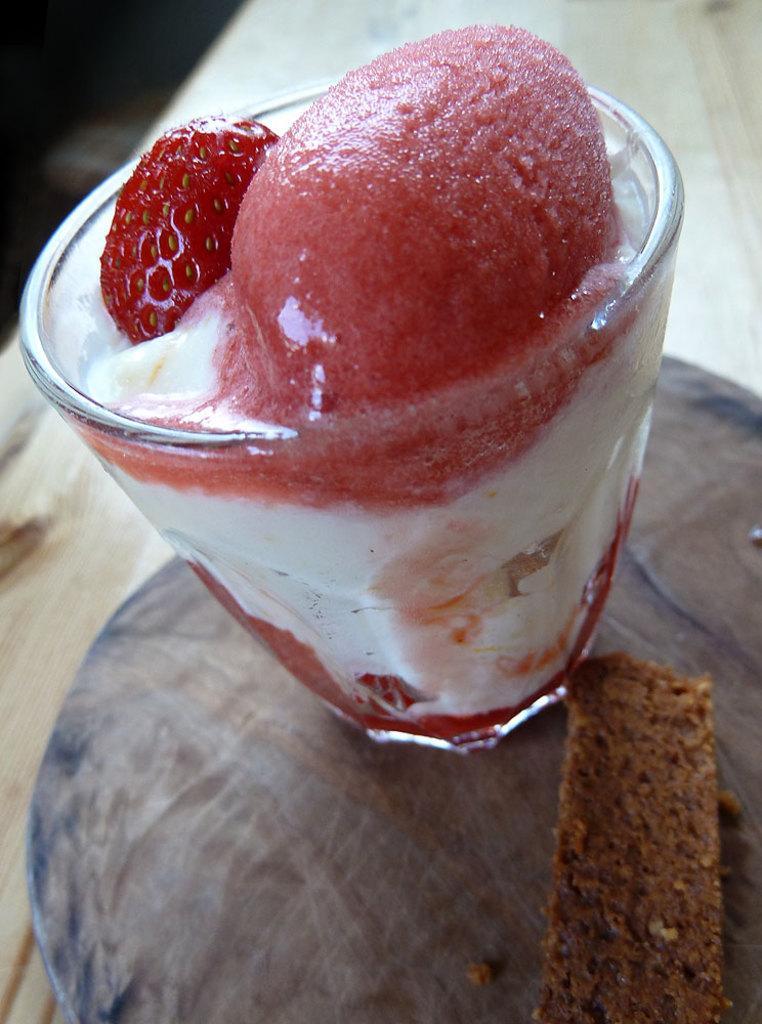How would you summarize this image in a sentence or two? In this image we can see desert in a glass placed on the table. 